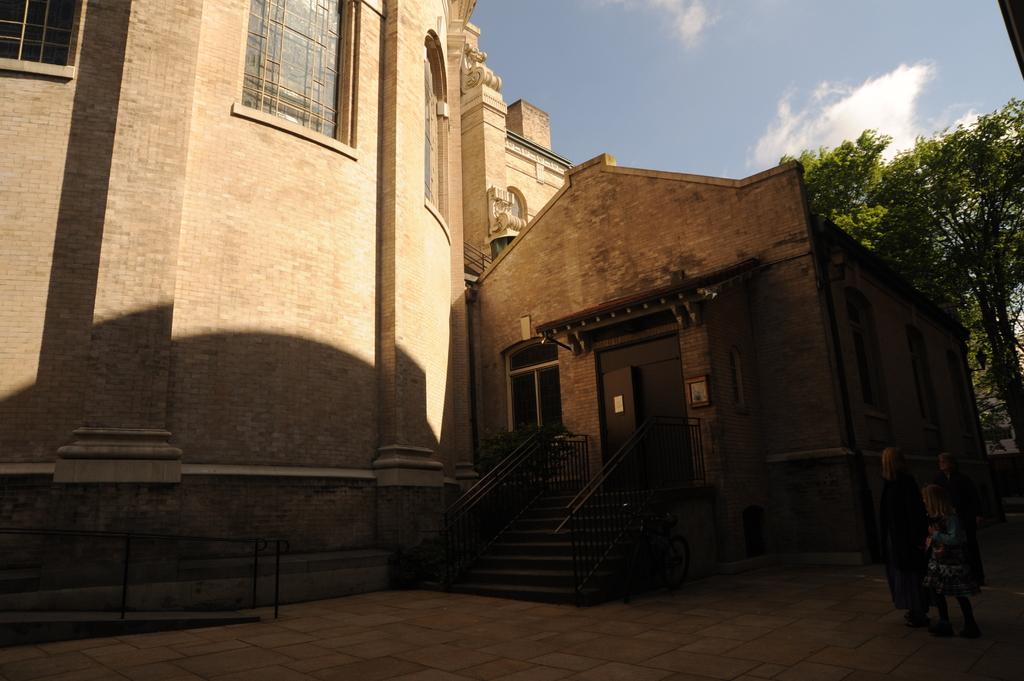Please provide a concise description of this image. In this picture we can see three people on the ground, steps, trees, buildings with windows, doors, some objects and in the background we can see the sky. 